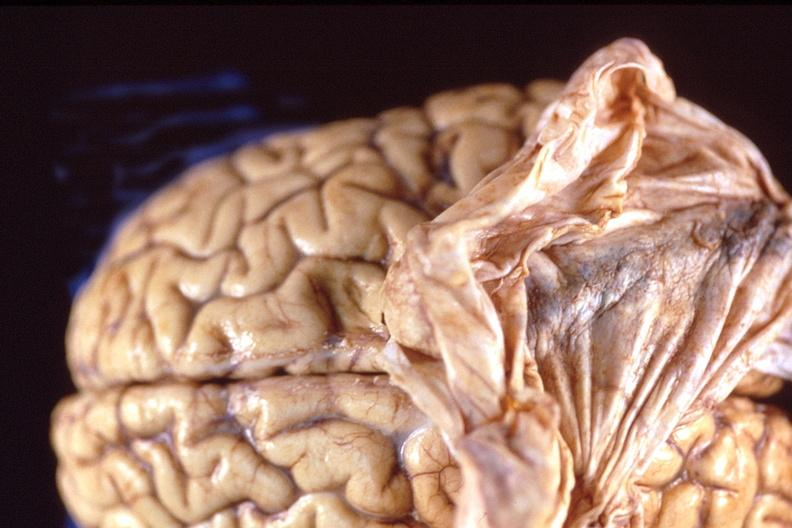what is present?
Answer the question using a single word or phrase. Nervous 